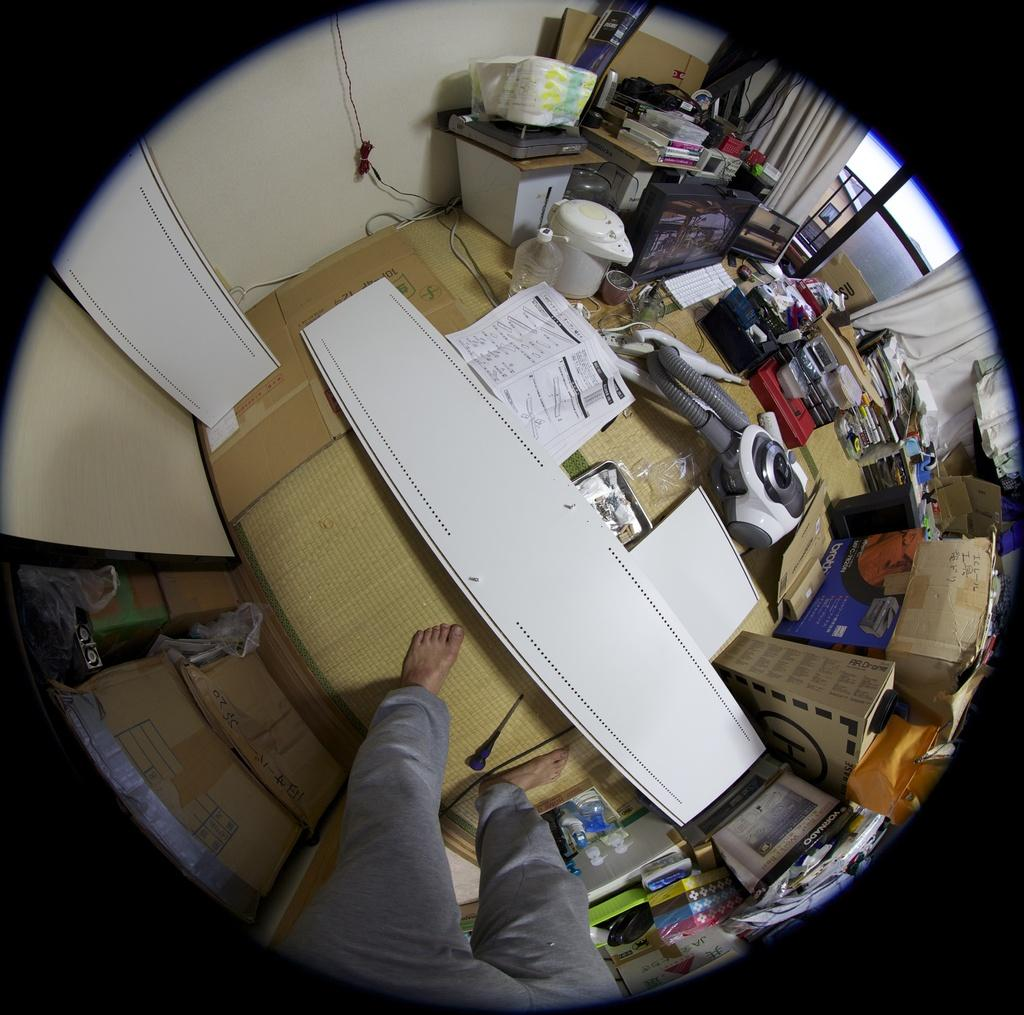What is the main subject in the image? There is a person in the image. What is the person interacting with in the image? The person is likely interacting with the table, as it is mentioned as being present in the image. What items can be seen on the table? Papers, stands, books, boxes, bottles, and possibly other objects are visible on the table. What type of background can be seen in the image? Curtains and covers are present in the image, suggesting that there may be a room or interior setting. Are there any additional items in the image? Card boards and a can are also present in the image. Can you see a doctor performing surgery in the image? No, there is no doctor or surgery scene present in the image. Is the person in the image flying an airplane? No, there is no airplane or indication of flying in the image. 